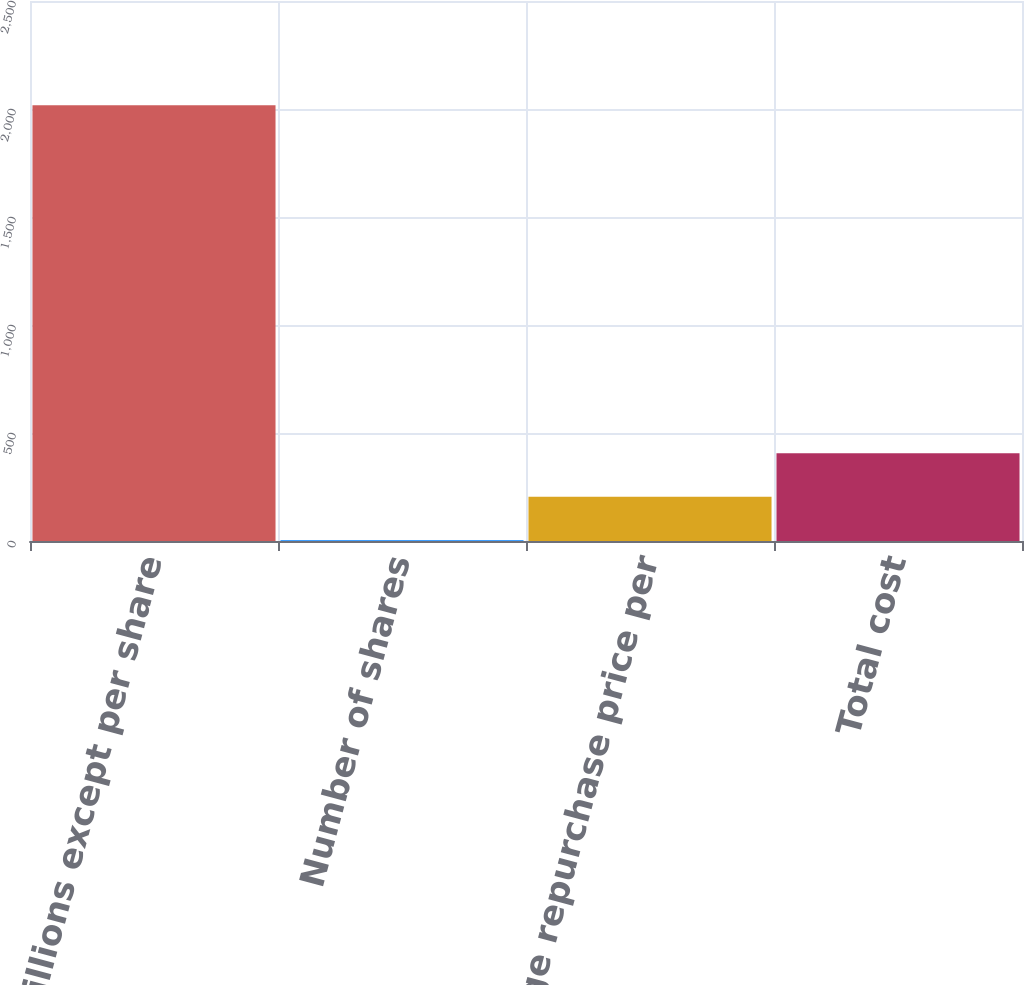Convert chart. <chart><loc_0><loc_0><loc_500><loc_500><bar_chart><fcel>(In millions except per share<fcel>Number of shares<fcel>Average repurchase price per<fcel>Total cost<nl><fcel>2017<fcel>3.3<fcel>204.67<fcel>406.04<nl></chart> 